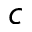Convert formula to latex. <formula><loc_0><loc_0><loc_500><loc_500>c</formula> 